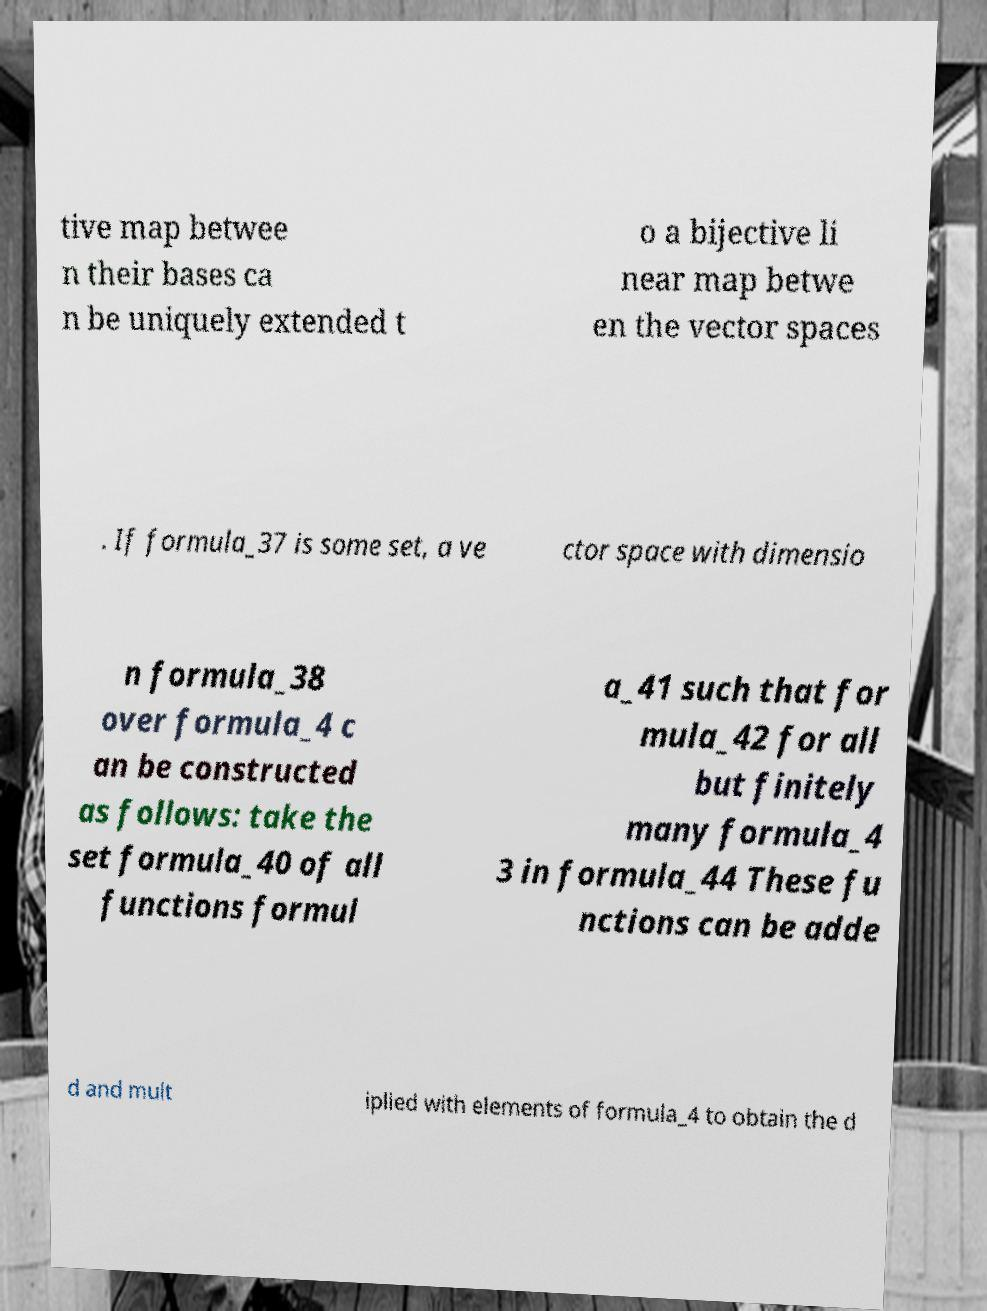I need the written content from this picture converted into text. Can you do that? tive map betwee n their bases ca n be uniquely extended t o a bijective li near map betwe en the vector spaces . If formula_37 is some set, a ve ctor space with dimensio n formula_38 over formula_4 c an be constructed as follows: take the set formula_40 of all functions formul a_41 such that for mula_42 for all but finitely many formula_4 3 in formula_44 These fu nctions can be adde d and mult iplied with elements of formula_4 to obtain the d 